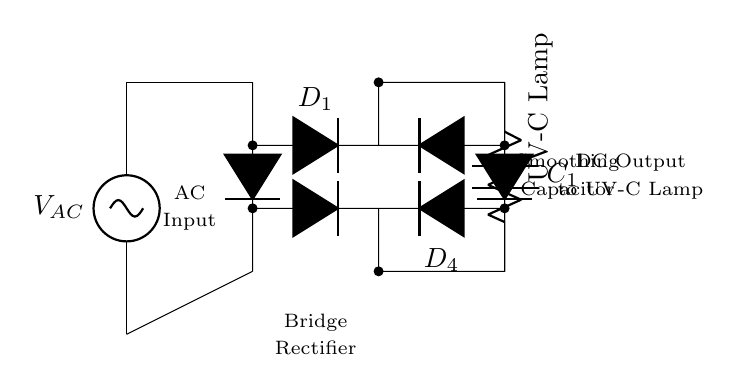What is the type of current provided by the rectifier? The rectifier converts alternating current from the AC source into direct current, which is used by the UV-C lamp.
Answer: Direct current What is the component that smooths the output voltage? The capacitor connected in parallel with the load resistor serves to reduce voltage fluctuations and smooth the output to provide a more stable DC signal to the UV-C lamp.
Answer: Capacitor How many diodes are used in the bridge rectifier? The circuit uses four diodes configured in a bridge arrangement to convert AC to DC effectively.
Answer: Four What is the load represented in the circuit? The load in this circuit is the UV-C lamp, which requires a certain DC voltage to operate for sterilization purposes.
Answer: UV-C lamp What is the purpose of the bridge rectifier? The bridge rectifier’s primary function is to provide full-wave rectification, allowing the output to utilize both halves of the AC waveform effectively.
Answer: Full-wave rectification What is the value of the AC voltage source? The AC voltage source is not explicitly labeled in the diagram, so it can be inferred that it would typically be a standard voltage, such as 120V or 240V, depending on regional standards.
Answer: Not specified 